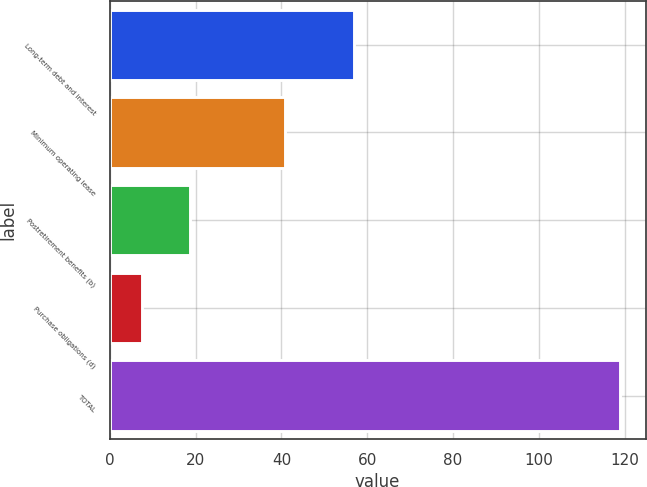<chart> <loc_0><loc_0><loc_500><loc_500><bar_chart><fcel>Long-term debt and interest<fcel>Minimum operating lease<fcel>Postretirement benefits (b)<fcel>Purchase obligations (d)<fcel>TOTAL<nl><fcel>56.9<fcel>40.8<fcel>18.73<fcel>7.6<fcel>118.9<nl></chart> 